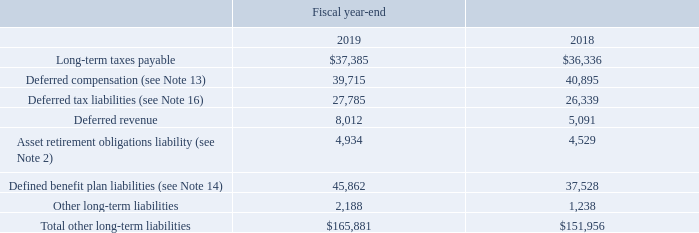9. BALANCE SHEET DETAILS (Continued)
Other long-term liabilities consist of the following (in thousands):
What was Long-term taxes payable in 2019?
Answer scale should be: thousand. $37,385. What was  Total other long-term liabilities  in 2018?
Answer scale should be: thousand. $151,956. In which years were long-term liabilities calculated? 2019, 2018. In which year was Other long-term liabilities larger? 2,188>1,238
Answer: 2019. What was the change in Other long-term liabilities from 2018 to 2019?
Answer scale should be: thousand. 2,188-1,238
Answer: 950. What was the percentage change in Other long-term liabilities from 2018 to 2019?
Answer scale should be: percent. (2,188-1,238)/1,238
Answer: 76.74. 